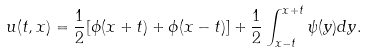<formula> <loc_0><loc_0><loc_500><loc_500>u ( t , x ) = \frac { 1 } { 2 } [ \phi ( x + t ) + \phi ( x - t ) ] + \frac { 1 } { 2 } \int _ { x - t } ^ { x + t } \psi ( y ) d y .</formula> 